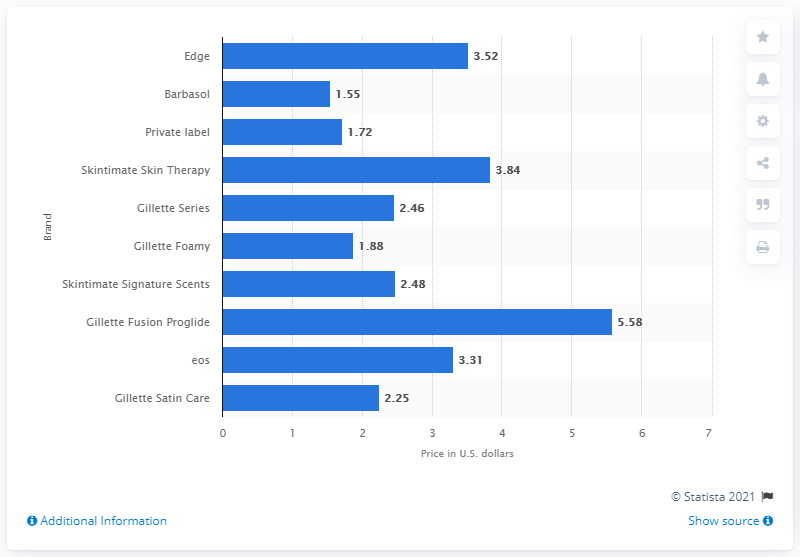Point out several critical features in this image. In 2019, the average price of Edge shaving cream in the United States was 3.52. In 2019, the average price of Barbasol products in the United States was 1.55. 